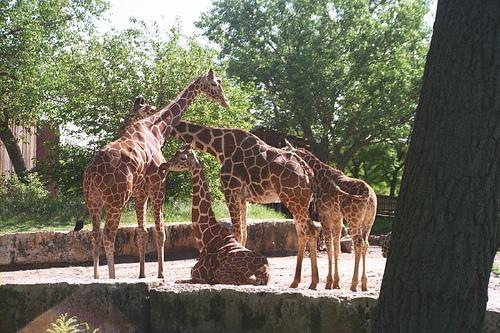How many giraffes are standing in the middle of the stone enclosure? Please explain your reasoning. four. One is laying down out of the group of 4 